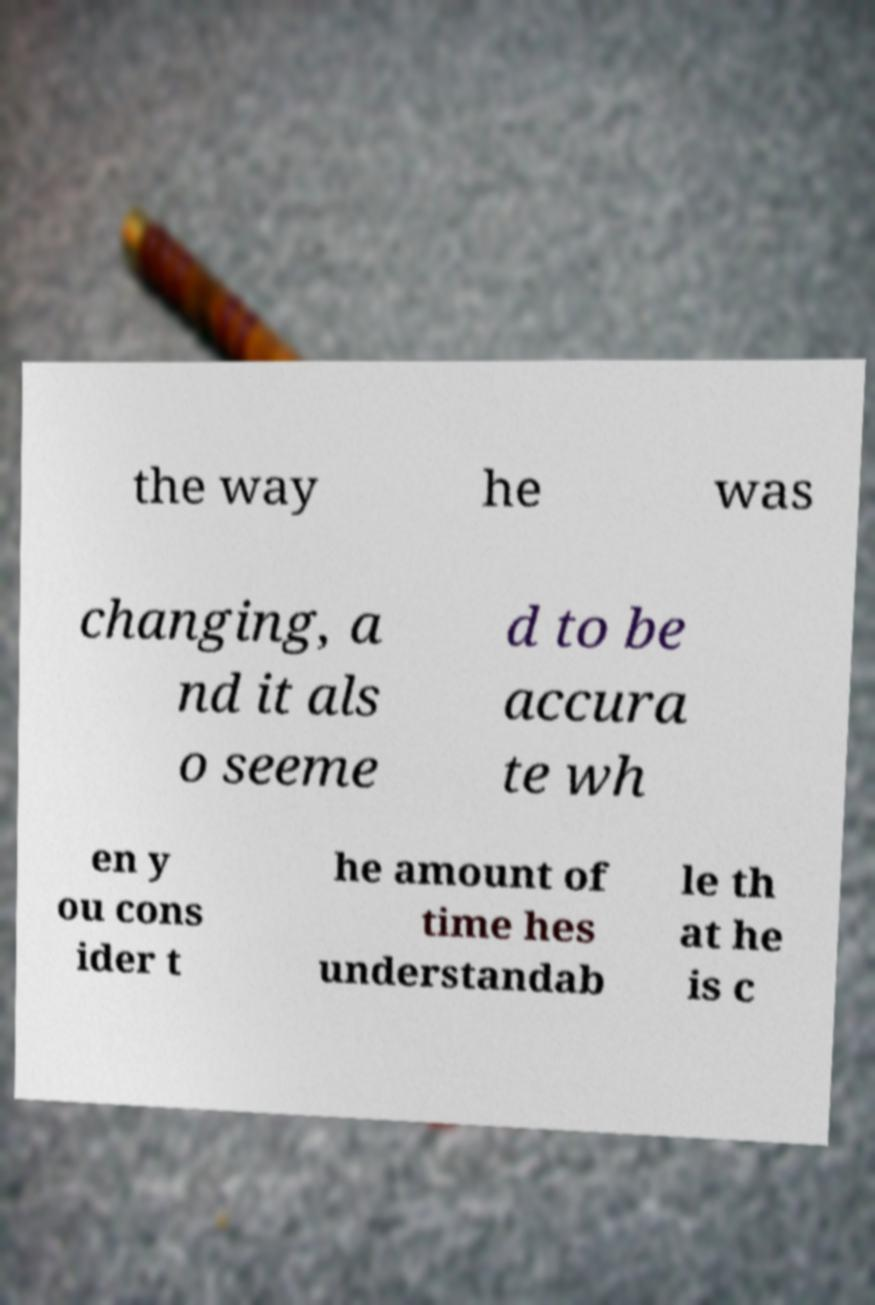Please identify and transcribe the text found in this image. the way he was changing, a nd it als o seeme d to be accura te wh en y ou cons ider t he amount of time hes understandab le th at he is c 